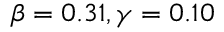Convert formula to latex. <formula><loc_0><loc_0><loc_500><loc_500>\beta = 0 . 3 1 , \gamma = 0 . 1 0</formula> 